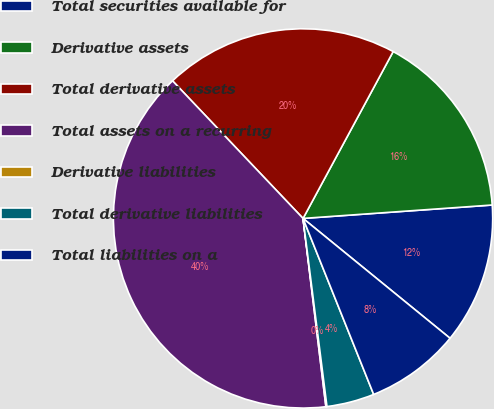<chart> <loc_0><loc_0><loc_500><loc_500><pie_chart><fcel>Total securities available for<fcel>Derivative assets<fcel>Total derivative assets<fcel>Total assets on a recurring<fcel>Derivative liabilities<fcel>Total derivative liabilities<fcel>Total liabilities on a<nl><fcel>12.01%<fcel>15.99%<fcel>19.96%<fcel>39.84%<fcel>0.09%<fcel>4.06%<fcel>8.04%<nl></chart> 